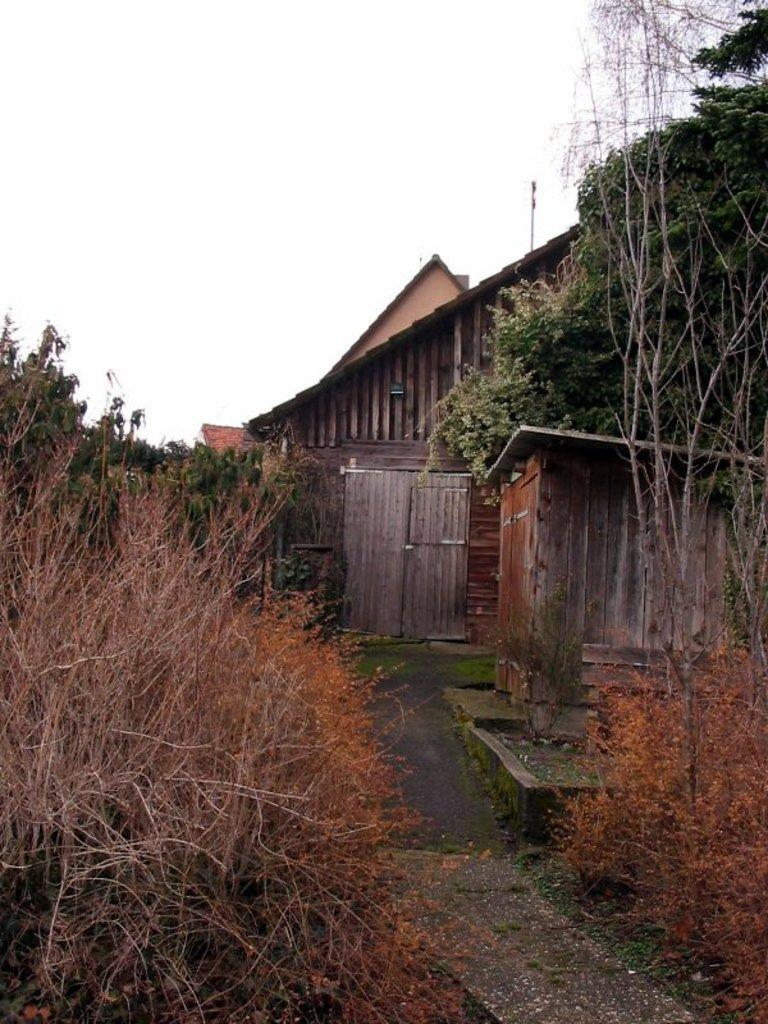What is the main feature of the image? There is a road in the image. What can be seen on both sides of the road? There are trees on both sides of the road. What type of structures are present in the image? There are buildings in the image. Can you describe a specific detail about one of the buildings? There is a door visible in the image. What else can be seen in the image besides the road, trees, and buildings? There is a pole in the image. What is visible in the background of the image? The sky is visible in the background of the image. How many tickets are visible in the image? There are no tickets present in the image. What type of man can be seen walking on the road in the image? There is no man present in the image, and therefore no one is walking on the road. 